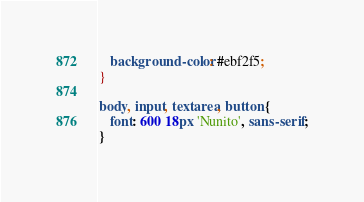Convert code to text. <code><loc_0><loc_0><loc_500><loc_500><_CSS_>   background-color: #ebf2f5;
}

body, input, textarea, button {
   font: 600 18px 'Nunito', sans-serif;
}</code> 